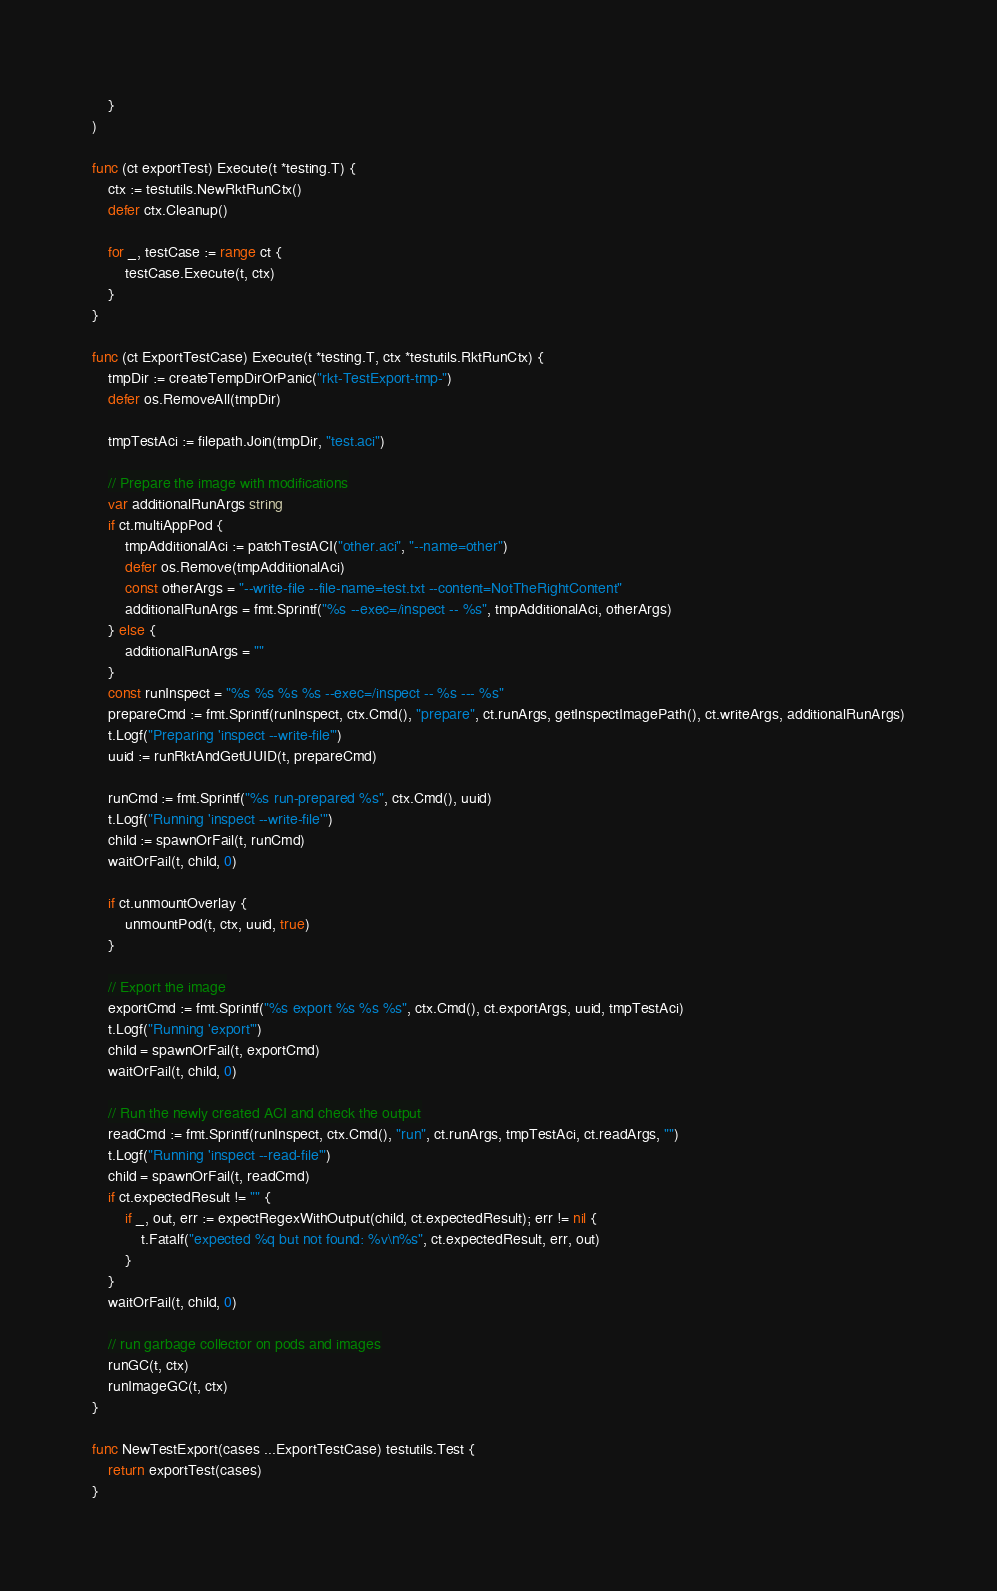<code> <loc_0><loc_0><loc_500><loc_500><_Go_>	}
)

func (ct exportTest) Execute(t *testing.T) {
	ctx := testutils.NewRktRunCtx()
	defer ctx.Cleanup()

	for _, testCase := range ct {
		testCase.Execute(t, ctx)
	}
}

func (ct ExportTestCase) Execute(t *testing.T, ctx *testutils.RktRunCtx) {
	tmpDir := createTempDirOrPanic("rkt-TestExport-tmp-")
	defer os.RemoveAll(tmpDir)

	tmpTestAci := filepath.Join(tmpDir, "test.aci")

	// Prepare the image with modifications
	var additionalRunArgs string
	if ct.multiAppPod {
		tmpAdditionalAci := patchTestACI("other.aci", "--name=other")
		defer os.Remove(tmpAdditionalAci)
		const otherArgs = "--write-file --file-name=test.txt --content=NotTheRightContent"
		additionalRunArgs = fmt.Sprintf("%s --exec=/inspect -- %s", tmpAdditionalAci, otherArgs)
	} else {
		additionalRunArgs = ""
	}
	const runInspect = "%s %s %s %s --exec=/inspect -- %s --- %s"
	prepareCmd := fmt.Sprintf(runInspect, ctx.Cmd(), "prepare", ct.runArgs, getInspectImagePath(), ct.writeArgs, additionalRunArgs)
	t.Logf("Preparing 'inspect --write-file'")
	uuid := runRktAndGetUUID(t, prepareCmd)

	runCmd := fmt.Sprintf("%s run-prepared %s", ctx.Cmd(), uuid)
	t.Logf("Running 'inspect --write-file'")
	child := spawnOrFail(t, runCmd)
	waitOrFail(t, child, 0)

	if ct.unmountOverlay {
		unmountPod(t, ctx, uuid, true)
	}

	// Export the image
	exportCmd := fmt.Sprintf("%s export %s %s %s", ctx.Cmd(), ct.exportArgs, uuid, tmpTestAci)
	t.Logf("Running 'export'")
	child = spawnOrFail(t, exportCmd)
	waitOrFail(t, child, 0)

	// Run the newly created ACI and check the output
	readCmd := fmt.Sprintf(runInspect, ctx.Cmd(), "run", ct.runArgs, tmpTestAci, ct.readArgs, "")
	t.Logf("Running 'inspect --read-file'")
	child = spawnOrFail(t, readCmd)
	if ct.expectedResult != "" {
		if _, out, err := expectRegexWithOutput(child, ct.expectedResult); err != nil {
			t.Fatalf("expected %q but not found: %v\n%s", ct.expectedResult, err, out)
		}
	}
	waitOrFail(t, child, 0)

	// run garbage collector on pods and images
	runGC(t, ctx)
	runImageGC(t, ctx)
}

func NewTestExport(cases ...ExportTestCase) testutils.Test {
	return exportTest(cases)
}
</code> 